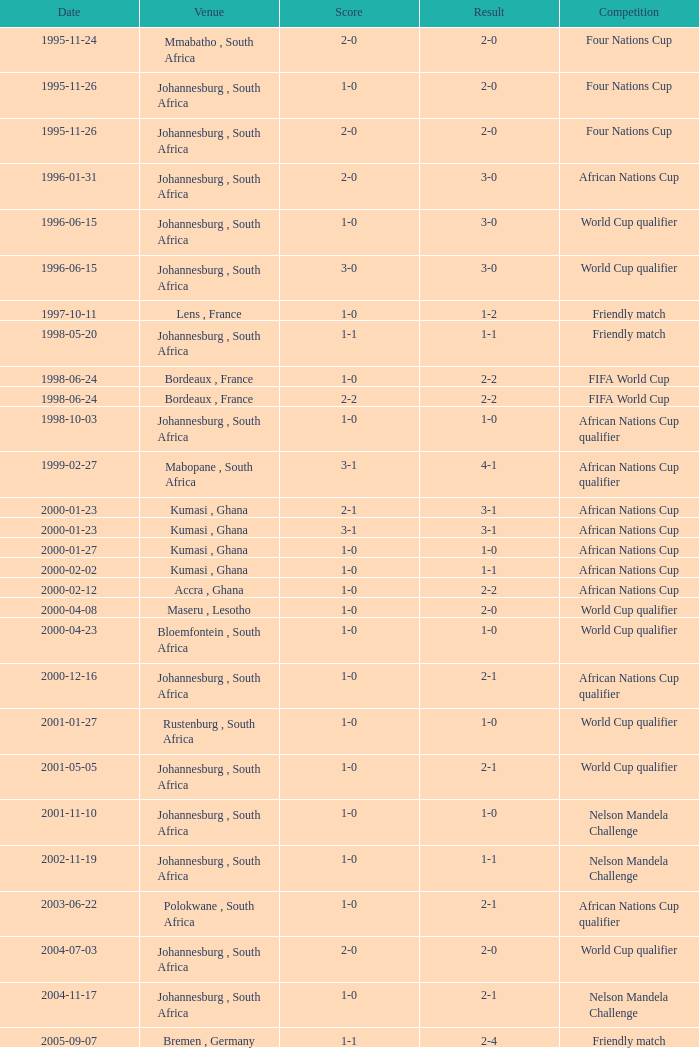Where was the contest held on the 5th of may, 2001? Johannesburg , South Africa. 